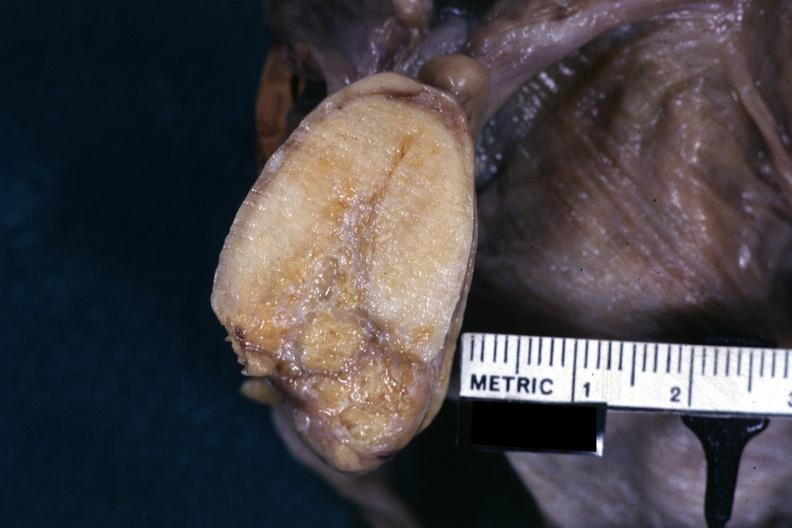s female reproductive present?
Answer the question using a single word or phrase. Yes 